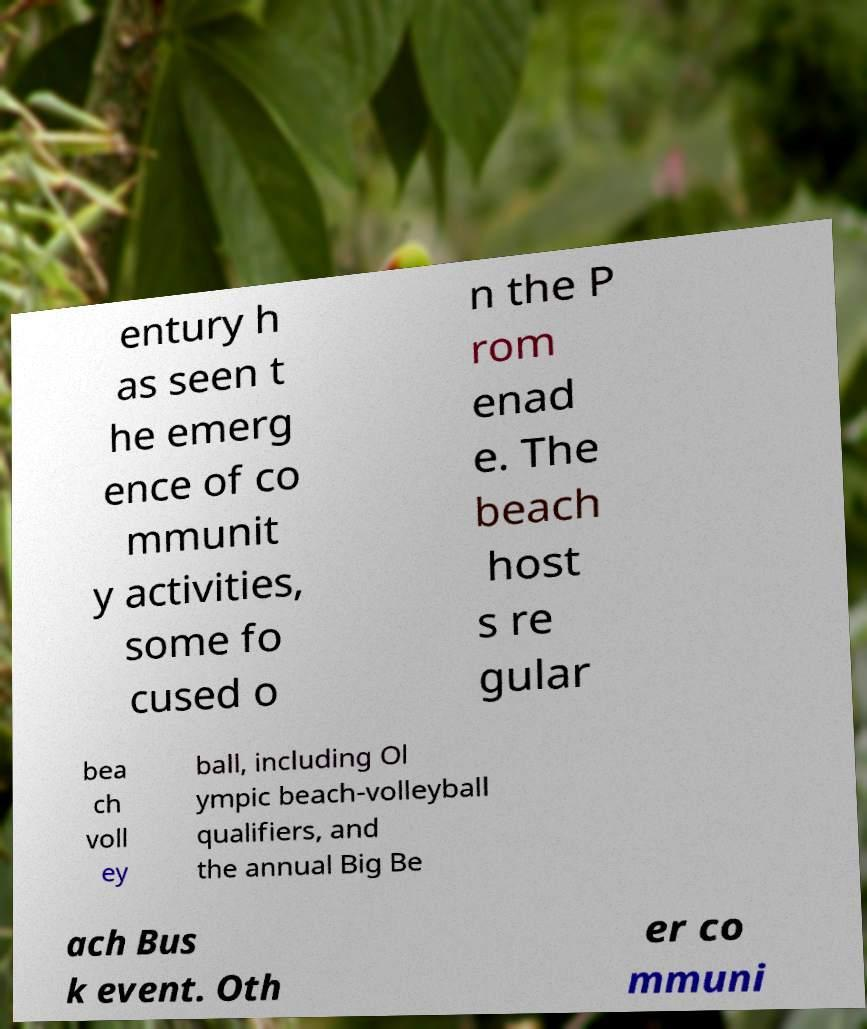Could you extract and type out the text from this image? entury h as seen t he emerg ence of co mmunit y activities, some fo cused o n the P rom enad e. The beach host s re gular bea ch voll ey ball, including Ol ympic beach-volleyball qualifiers, and the annual Big Be ach Bus k event. Oth er co mmuni 